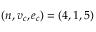<formula> <loc_0><loc_0><loc_500><loc_500>( n , v _ { c } , e _ { c } ) = ( 4 , 1 , 5 )</formula> 